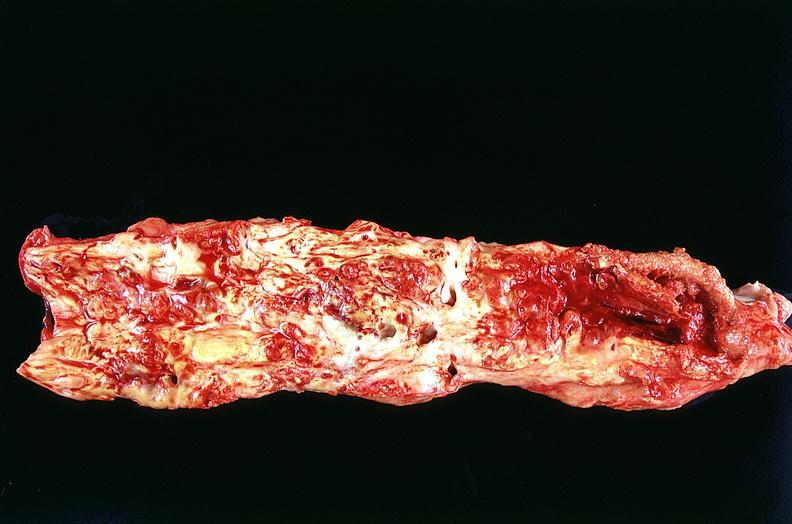s beckwith-wiedemann syndrome present?
Answer the question using a single word or phrase. No 